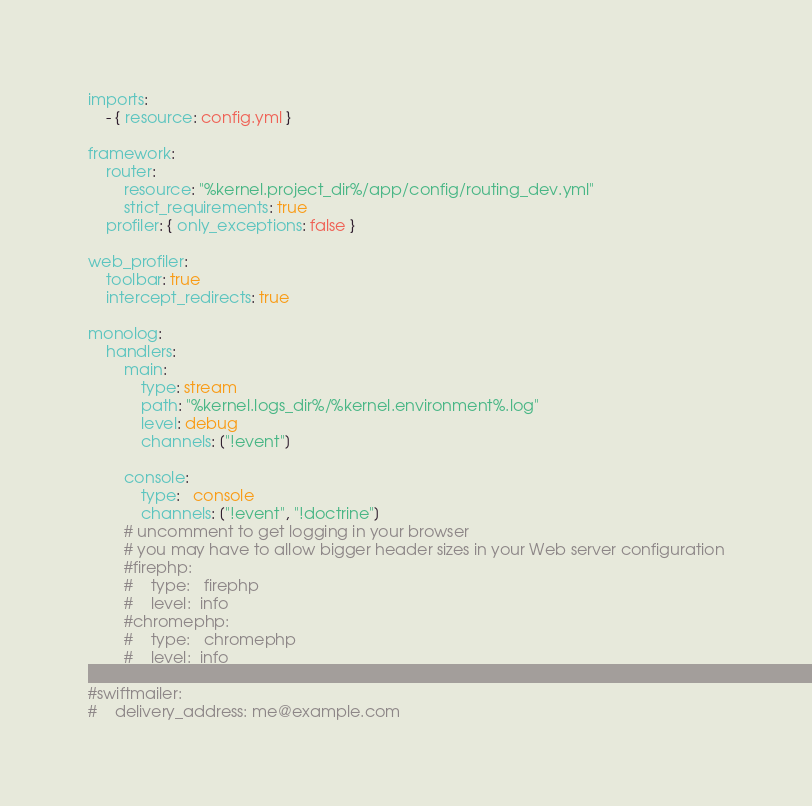<code> <loc_0><loc_0><loc_500><loc_500><_YAML_>imports:
    - { resource: config.yml }

framework:
    router:
        resource: "%kernel.project_dir%/app/config/routing_dev.yml"
        strict_requirements: true
    profiler: { only_exceptions: false }

web_profiler:
    toolbar: true
    intercept_redirects: true

monolog:
    handlers:
        main:
            type: stream
            path: "%kernel.logs_dir%/%kernel.environment%.log"
            level: debug
            channels: ["!event"]

        console:
            type:   console
            channels: ["!event", "!doctrine"]
        # uncomment to get logging in your browser
        # you may have to allow bigger header sizes in your Web server configuration
        #firephp:
        #    type:   firephp
        #    level:  info
        #chromephp:
        #    type:   chromephp
        #    level:  info

#swiftmailer:
#    delivery_address: me@example.com
</code> 